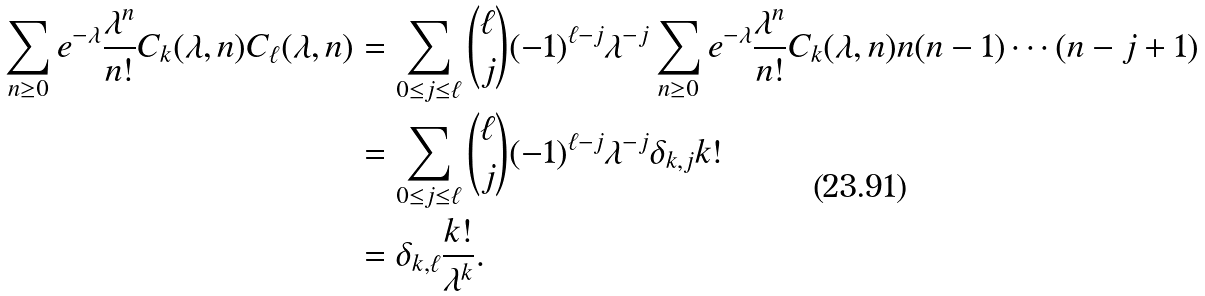<formula> <loc_0><loc_0><loc_500><loc_500>\sum _ { n \geq 0 } e ^ { - \lambda } \frac { \lambda ^ { n } } { n ! } C _ { k } ( \lambda , n ) C _ { \ell } ( \lambda , n ) & = \sum _ { 0 \leq j \leq \ell } \binom { \ell } { j } ( - 1 ) ^ { \ell - j } { \lambda ^ { - j } } \sum _ { n \geq 0 } e ^ { - \lambda } \frac { \lambda ^ { n } } { n ! } C _ { k } ( \lambda , n ) { n ( n - 1 ) \cdots ( n - j + 1 ) } \\ & = \sum _ { 0 \leq j \leq \ell } \binom { \ell } { j } ( - 1 ) ^ { \ell - j } { \lambda ^ { - j } } \delta _ { k , j } k ! \\ & = \delta _ { k , \ell } \frac { k ! } { \lambda ^ { k } } .</formula> 